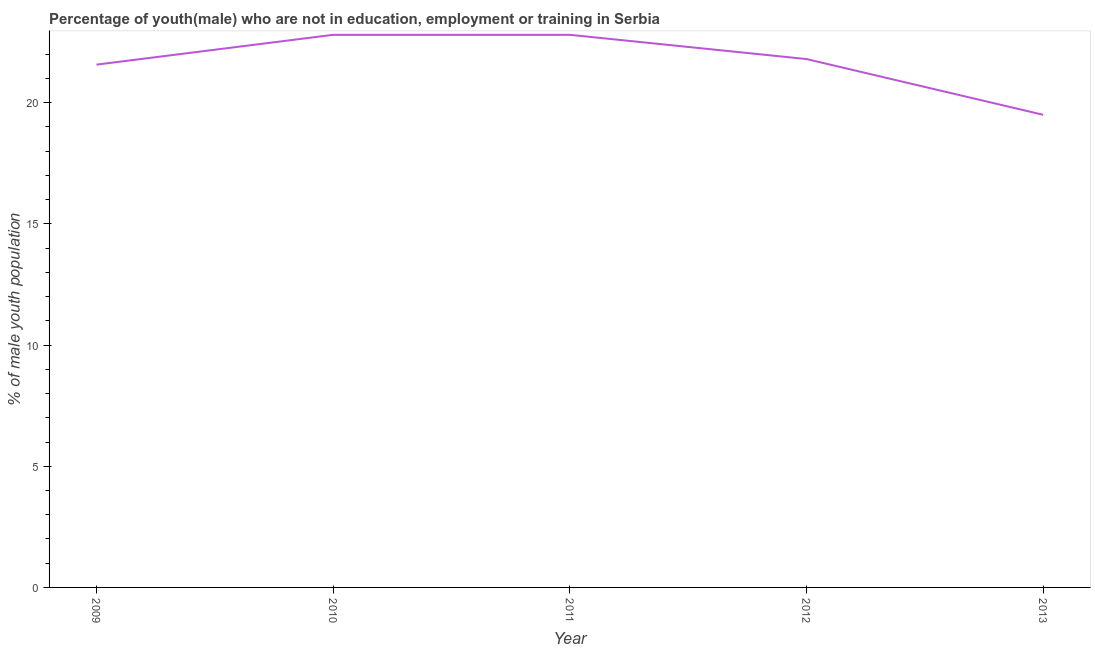What is the unemployed male youth population in 2010?
Make the answer very short. 22.8. Across all years, what is the maximum unemployed male youth population?
Provide a short and direct response. 22.8. In which year was the unemployed male youth population maximum?
Give a very brief answer. 2010. What is the sum of the unemployed male youth population?
Offer a terse response. 108.47. What is the difference between the unemployed male youth population in 2010 and 2012?
Provide a succinct answer. 1. What is the average unemployed male youth population per year?
Make the answer very short. 21.69. What is the median unemployed male youth population?
Your answer should be very brief. 21.8. In how many years, is the unemployed male youth population greater than 7 %?
Offer a very short reply. 5. Do a majority of the years between 2013 and 2009 (inclusive) have unemployed male youth population greater than 21 %?
Your response must be concise. Yes. What is the ratio of the unemployed male youth population in 2012 to that in 2013?
Give a very brief answer. 1.12. Is the unemployed male youth population in 2010 less than that in 2013?
Give a very brief answer. No. What is the difference between the highest and the second highest unemployed male youth population?
Provide a short and direct response. 0. What is the difference between the highest and the lowest unemployed male youth population?
Offer a very short reply. 3.3. In how many years, is the unemployed male youth population greater than the average unemployed male youth population taken over all years?
Your answer should be very brief. 3. How many years are there in the graph?
Make the answer very short. 5. Does the graph contain any zero values?
Keep it short and to the point. No. What is the title of the graph?
Your response must be concise. Percentage of youth(male) who are not in education, employment or training in Serbia. What is the label or title of the Y-axis?
Provide a short and direct response. % of male youth population. What is the % of male youth population of 2009?
Give a very brief answer. 21.57. What is the % of male youth population of 2010?
Offer a very short reply. 22.8. What is the % of male youth population in 2011?
Make the answer very short. 22.8. What is the % of male youth population of 2012?
Your answer should be very brief. 21.8. What is the % of male youth population of 2013?
Your answer should be very brief. 19.5. What is the difference between the % of male youth population in 2009 and 2010?
Offer a terse response. -1.23. What is the difference between the % of male youth population in 2009 and 2011?
Offer a very short reply. -1.23. What is the difference between the % of male youth population in 2009 and 2012?
Offer a very short reply. -0.23. What is the difference between the % of male youth population in 2009 and 2013?
Provide a short and direct response. 2.07. What is the difference between the % of male youth population in 2010 and 2013?
Provide a short and direct response. 3.3. What is the difference between the % of male youth population in 2011 and 2012?
Make the answer very short. 1. What is the difference between the % of male youth population in 2012 and 2013?
Your answer should be compact. 2.3. What is the ratio of the % of male youth population in 2009 to that in 2010?
Provide a succinct answer. 0.95. What is the ratio of the % of male youth population in 2009 to that in 2011?
Give a very brief answer. 0.95. What is the ratio of the % of male youth population in 2009 to that in 2012?
Ensure brevity in your answer.  0.99. What is the ratio of the % of male youth population in 2009 to that in 2013?
Your answer should be compact. 1.11. What is the ratio of the % of male youth population in 2010 to that in 2012?
Make the answer very short. 1.05. What is the ratio of the % of male youth population in 2010 to that in 2013?
Provide a short and direct response. 1.17. What is the ratio of the % of male youth population in 2011 to that in 2012?
Offer a very short reply. 1.05. What is the ratio of the % of male youth population in 2011 to that in 2013?
Offer a terse response. 1.17. What is the ratio of the % of male youth population in 2012 to that in 2013?
Keep it short and to the point. 1.12. 